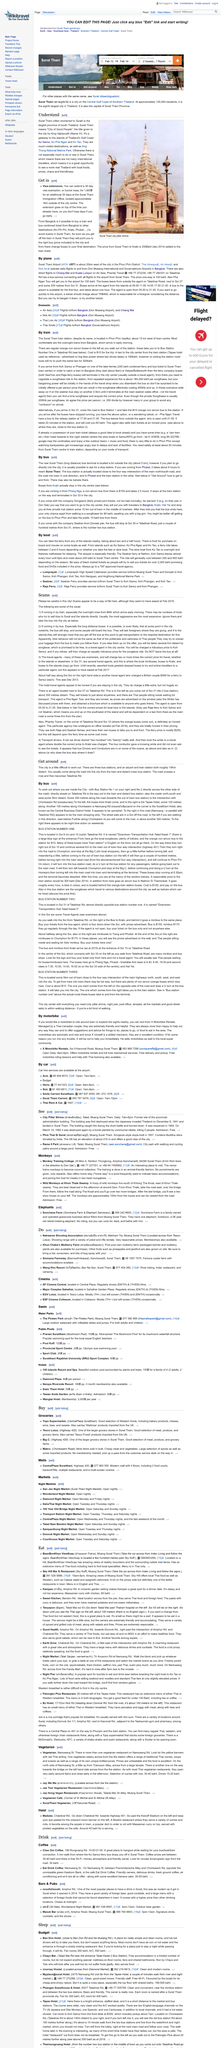List a handful of essential elements in this visual. Surat Thani is commonly referred to as Surat. The city was given the title of "City of Good People" by King Vajiravudhu (Rama VI). Surat Thani means 'City of Good People' in English. 